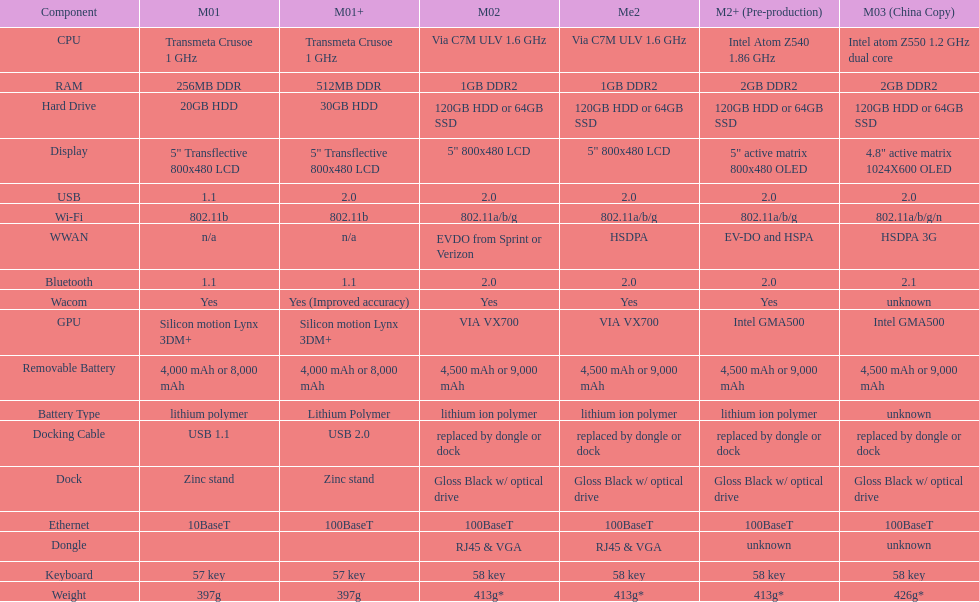Which model provides a larger hard drive: model 01 or model 02? Model 02. 